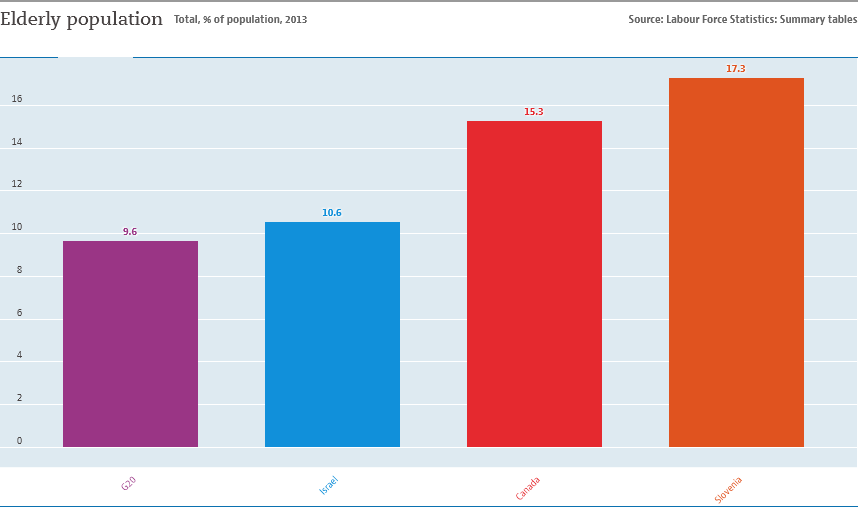Identify some key points in this picture. The difference in the values between the red bar and the blue bar is greater than 4, and the answer is yes. The elderly population in Canada represents approximately 1.53% of the total population. 